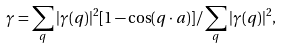<formula> <loc_0><loc_0><loc_500><loc_500>\gamma = \sum _ { q } | \gamma ( { q } ) | ^ { 2 } [ 1 - \cos ( { q \cdot a } ) ] / \sum _ { q } | \gamma ( { q } ) | ^ { 2 } ,</formula> 